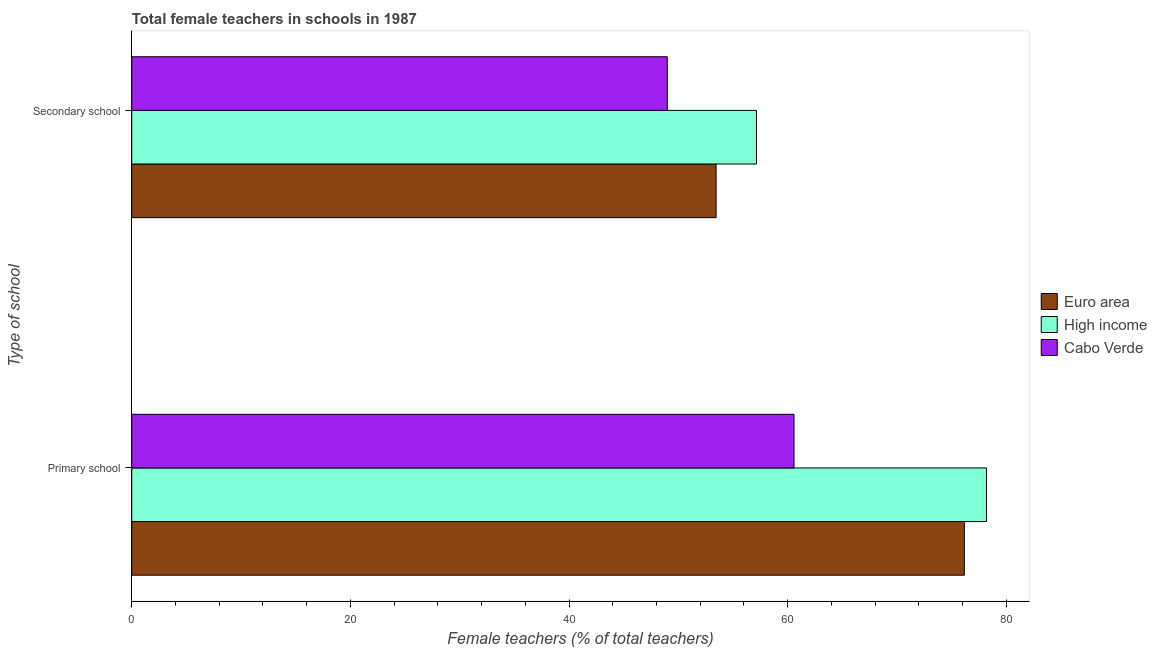How many different coloured bars are there?
Provide a short and direct response. 3. How many bars are there on the 1st tick from the top?
Offer a terse response. 3. What is the label of the 2nd group of bars from the top?
Your response must be concise. Primary school. What is the percentage of female teachers in primary schools in High income?
Provide a short and direct response. 78.19. Across all countries, what is the maximum percentage of female teachers in secondary schools?
Give a very brief answer. 57.15. Across all countries, what is the minimum percentage of female teachers in secondary schools?
Provide a short and direct response. 48.99. In which country was the percentage of female teachers in primary schools minimum?
Keep it short and to the point. Cabo Verde. What is the total percentage of female teachers in secondary schools in the graph?
Your response must be concise. 159.59. What is the difference between the percentage of female teachers in primary schools in Euro area and that in High income?
Keep it short and to the point. -2.03. What is the difference between the percentage of female teachers in primary schools in Cabo Verde and the percentage of female teachers in secondary schools in High income?
Keep it short and to the point. 3.43. What is the average percentage of female teachers in secondary schools per country?
Your answer should be very brief. 53.2. What is the difference between the percentage of female teachers in primary schools and percentage of female teachers in secondary schools in Cabo Verde?
Provide a short and direct response. 11.59. In how many countries, is the percentage of female teachers in secondary schools greater than 48 %?
Keep it short and to the point. 3. What is the ratio of the percentage of female teachers in primary schools in Euro area to that in High income?
Provide a short and direct response. 0.97. Is the percentage of female teachers in secondary schools in Cabo Verde less than that in High income?
Make the answer very short. Yes. In how many countries, is the percentage of female teachers in secondary schools greater than the average percentage of female teachers in secondary schools taken over all countries?
Make the answer very short. 2. What does the 2nd bar from the top in Primary school represents?
Provide a short and direct response. High income. What does the 3rd bar from the bottom in Secondary school represents?
Your answer should be very brief. Cabo Verde. Are all the bars in the graph horizontal?
Your answer should be very brief. Yes. How many legend labels are there?
Keep it short and to the point. 3. How are the legend labels stacked?
Make the answer very short. Vertical. What is the title of the graph?
Make the answer very short. Total female teachers in schools in 1987. Does "Peru" appear as one of the legend labels in the graph?
Ensure brevity in your answer.  No. What is the label or title of the X-axis?
Your answer should be very brief. Female teachers (% of total teachers). What is the label or title of the Y-axis?
Provide a succinct answer. Type of school. What is the Female teachers (% of total teachers) of Euro area in Primary school?
Offer a terse response. 76.16. What is the Female teachers (% of total teachers) of High income in Primary school?
Your response must be concise. 78.19. What is the Female teachers (% of total teachers) in Cabo Verde in Primary school?
Ensure brevity in your answer.  60.58. What is the Female teachers (% of total teachers) of Euro area in Secondary school?
Give a very brief answer. 53.45. What is the Female teachers (% of total teachers) in High income in Secondary school?
Offer a terse response. 57.15. What is the Female teachers (% of total teachers) in Cabo Verde in Secondary school?
Ensure brevity in your answer.  48.99. Across all Type of school, what is the maximum Female teachers (% of total teachers) of Euro area?
Give a very brief answer. 76.16. Across all Type of school, what is the maximum Female teachers (% of total teachers) of High income?
Offer a terse response. 78.19. Across all Type of school, what is the maximum Female teachers (% of total teachers) in Cabo Verde?
Ensure brevity in your answer.  60.58. Across all Type of school, what is the minimum Female teachers (% of total teachers) of Euro area?
Make the answer very short. 53.45. Across all Type of school, what is the minimum Female teachers (% of total teachers) in High income?
Offer a very short reply. 57.15. Across all Type of school, what is the minimum Female teachers (% of total teachers) in Cabo Verde?
Provide a short and direct response. 48.99. What is the total Female teachers (% of total teachers) of Euro area in the graph?
Offer a terse response. 129.62. What is the total Female teachers (% of total teachers) in High income in the graph?
Offer a very short reply. 135.34. What is the total Female teachers (% of total teachers) in Cabo Verde in the graph?
Your response must be concise. 109.57. What is the difference between the Female teachers (% of total teachers) of Euro area in Primary school and that in Secondary school?
Offer a very short reply. 22.71. What is the difference between the Female teachers (% of total teachers) in High income in Primary school and that in Secondary school?
Provide a succinct answer. 21.04. What is the difference between the Female teachers (% of total teachers) of Cabo Verde in Primary school and that in Secondary school?
Your answer should be compact. 11.59. What is the difference between the Female teachers (% of total teachers) in Euro area in Primary school and the Female teachers (% of total teachers) in High income in Secondary school?
Ensure brevity in your answer.  19.02. What is the difference between the Female teachers (% of total teachers) in Euro area in Primary school and the Female teachers (% of total teachers) in Cabo Verde in Secondary school?
Offer a terse response. 27.18. What is the difference between the Female teachers (% of total teachers) of High income in Primary school and the Female teachers (% of total teachers) of Cabo Verde in Secondary school?
Offer a terse response. 29.2. What is the average Female teachers (% of total teachers) of Euro area per Type of school?
Ensure brevity in your answer.  64.81. What is the average Female teachers (% of total teachers) of High income per Type of school?
Offer a very short reply. 67.67. What is the average Female teachers (% of total teachers) in Cabo Verde per Type of school?
Give a very brief answer. 54.78. What is the difference between the Female teachers (% of total teachers) in Euro area and Female teachers (% of total teachers) in High income in Primary school?
Give a very brief answer. -2.03. What is the difference between the Female teachers (% of total teachers) in Euro area and Female teachers (% of total teachers) in Cabo Verde in Primary school?
Give a very brief answer. 15.58. What is the difference between the Female teachers (% of total teachers) in High income and Female teachers (% of total teachers) in Cabo Verde in Primary school?
Your response must be concise. 17.61. What is the difference between the Female teachers (% of total teachers) of Euro area and Female teachers (% of total teachers) of High income in Secondary school?
Offer a terse response. -3.69. What is the difference between the Female teachers (% of total teachers) in Euro area and Female teachers (% of total teachers) in Cabo Verde in Secondary school?
Provide a short and direct response. 4.47. What is the difference between the Female teachers (% of total teachers) of High income and Female teachers (% of total teachers) of Cabo Verde in Secondary school?
Give a very brief answer. 8.16. What is the ratio of the Female teachers (% of total teachers) in Euro area in Primary school to that in Secondary school?
Offer a terse response. 1.42. What is the ratio of the Female teachers (% of total teachers) of High income in Primary school to that in Secondary school?
Offer a very short reply. 1.37. What is the ratio of the Female teachers (% of total teachers) of Cabo Verde in Primary school to that in Secondary school?
Make the answer very short. 1.24. What is the difference between the highest and the second highest Female teachers (% of total teachers) in Euro area?
Offer a very short reply. 22.71. What is the difference between the highest and the second highest Female teachers (% of total teachers) in High income?
Keep it short and to the point. 21.04. What is the difference between the highest and the second highest Female teachers (% of total teachers) of Cabo Verde?
Provide a short and direct response. 11.59. What is the difference between the highest and the lowest Female teachers (% of total teachers) of Euro area?
Offer a terse response. 22.71. What is the difference between the highest and the lowest Female teachers (% of total teachers) in High income?
Keep it short and to the point. 21.04. What is the difference between the highest and the lowest Female teachers (% of total teachers) in Cabo Verde?
Provide a succinct answer. 11.59. 